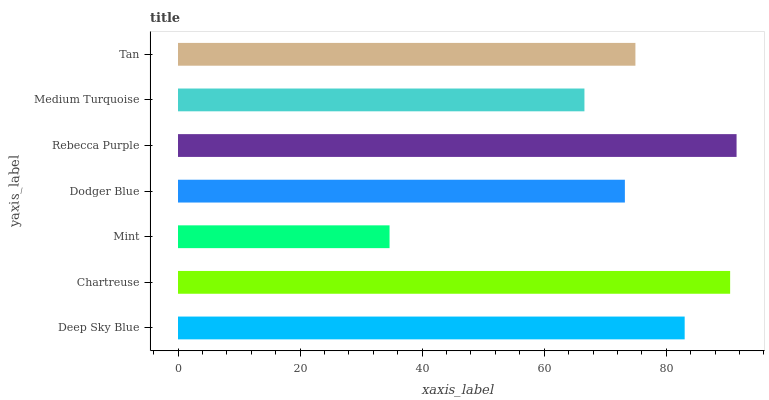Is Mint the minimum?
Answer yes or no. Yes. Is Rebecca Purple the maximum?
Answer yes or no. Yes. Is Chartreuse the minimum?
Answer yes or no. No. Is Chartreuse the maximum?
Answer yes or no. No. Is Chartreuse greater than Deep Sky Blue?
Answer yes or no. Yes. Is Deep Sky Blue less than Chartreuse?
Answer yes or no. Yes. Is Deep Sky Blue greater than Chartreuse?
Answer yes or no. No. Is Chartreuse less than Deep Sky Blue?
Answer yes or no. No. Is Tan the high median?
Answer yes or no. Yes. Is Tan the low median?
Answer yes or no. Yes. Is Deep Sky Blue the high median?
Answer yes or no. No. Is Medium Turquoise the low median?
Answer yes or no. No. 